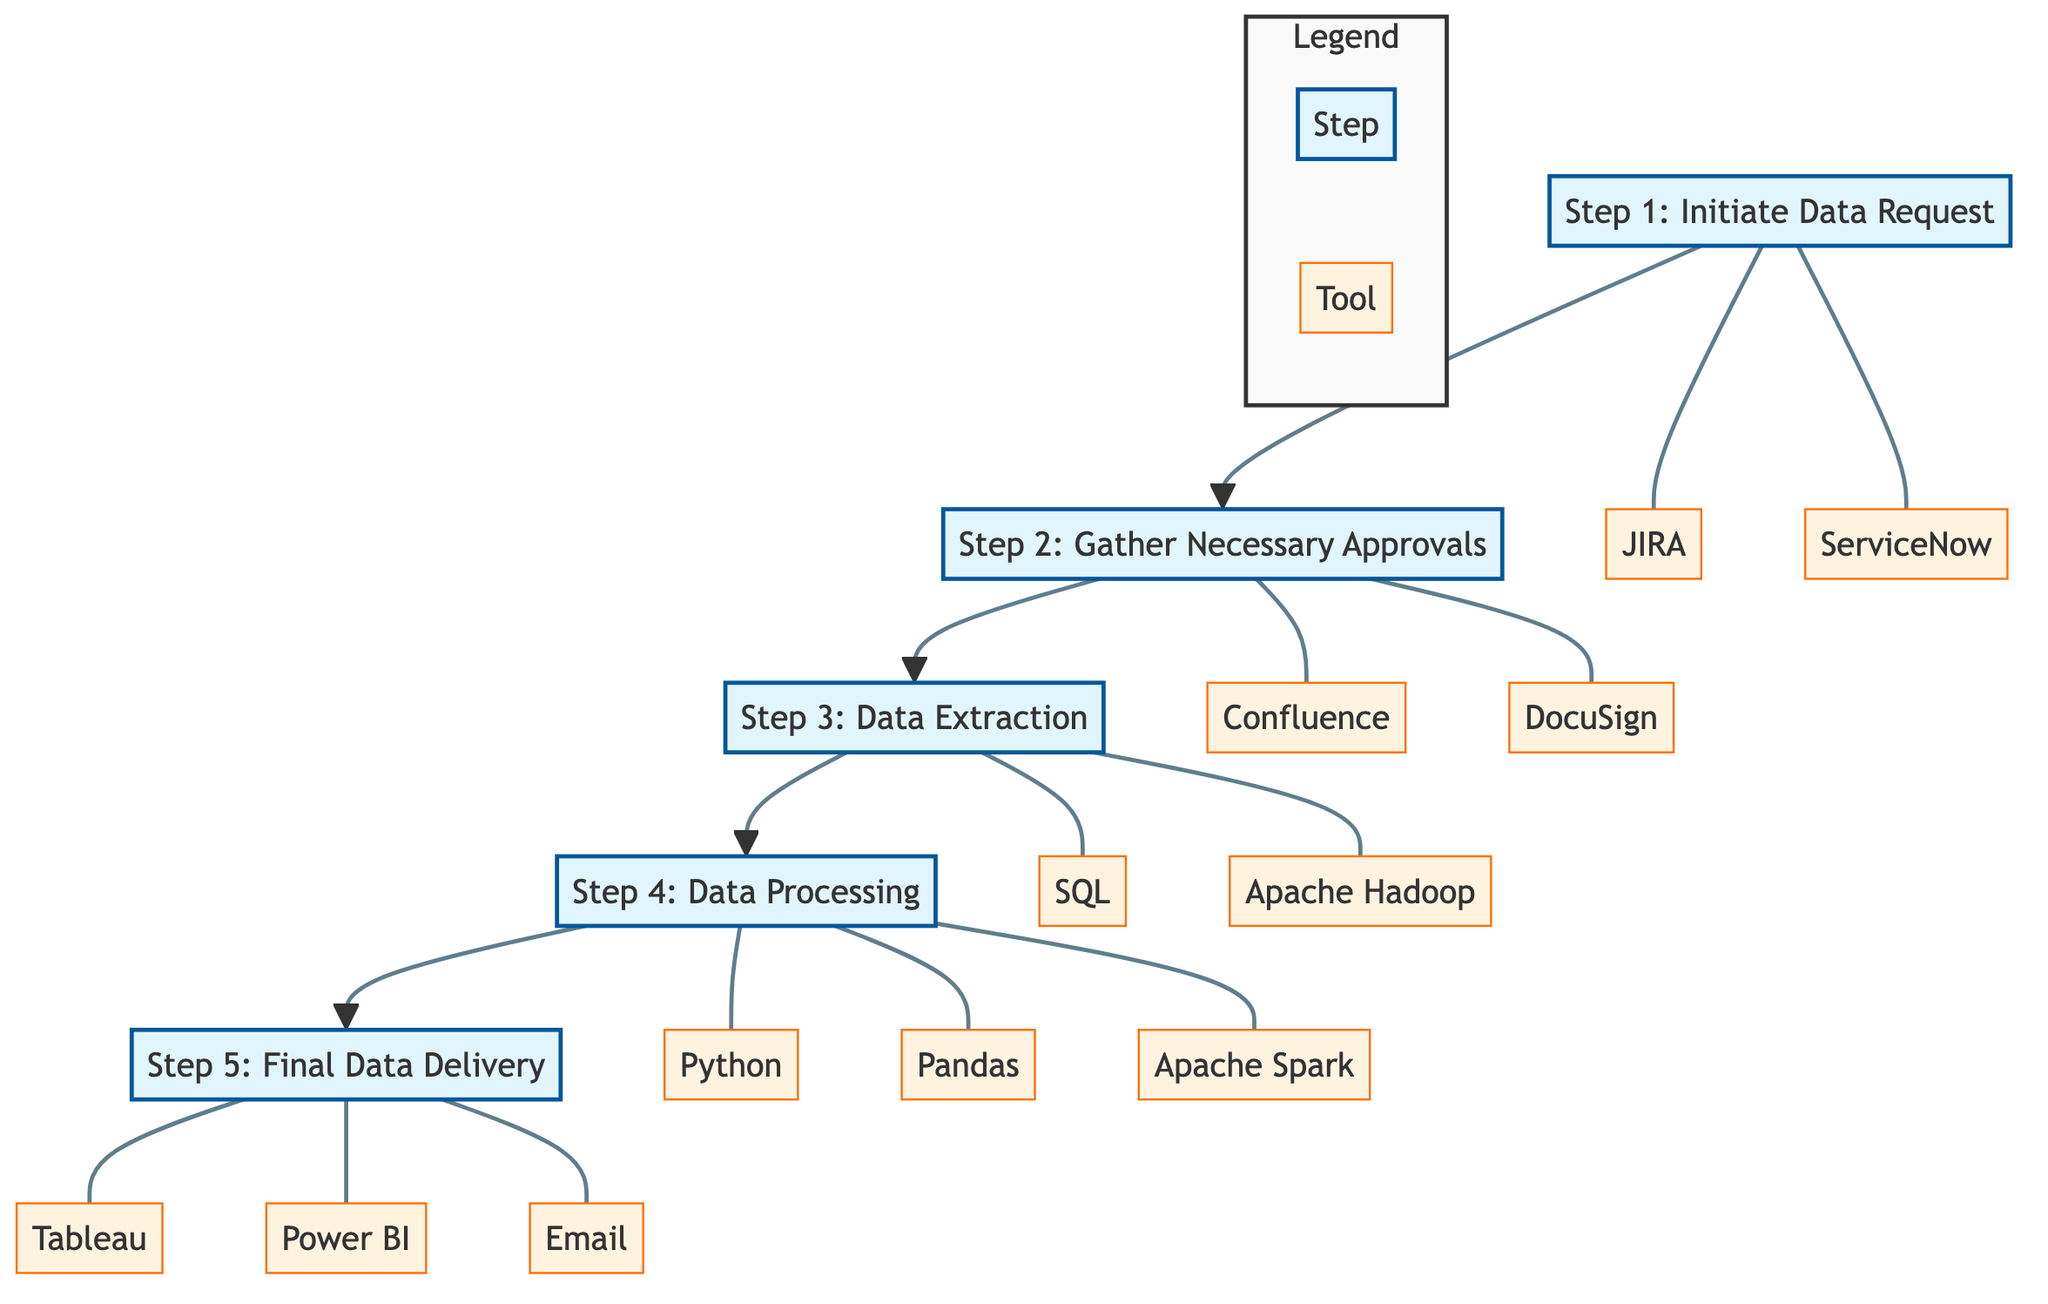What is the first step in the data request journey? The first step listed in the diagram is "Step 1: Initiate Data Request." This step indicates that a team member submits a formal request detailing the dataset and its purpose.
Answer: Step 1: Initiate Data Request Which party is responsible for gathering necessary approvals? The diagram specifies that the "Data Governance Team" is responsible for gathering necessary approvals before moving forward with the data request.
Answer: Data Governance Team How many tools are associated with Step 4: Data Processing? In the diagram, Step 4 lists three tools: Python, Pandas, and Apache Spark. Therefore, there are a total of three tools associated with this step.
Answer: 3 What is the relationship between Step 2 and Step 3? The diagram shows a direct flow from Step 2 ("Gather Necessary Approvals") to Step 3 ("Data Extraction"). This indicates that after approvals are gathered, the next logical step is to extract data.
Answer: Direct flow What tools are used in Step 1? The diagram for Step 1 indicates that two tools are used: JIRA and ServiceNow. Thus, the tools utilized in this step are these two applications.
Answer: JIRA, ServiceNow Identify the last step in the data request process. According to the diagram, the last step presented is "Step 5: Final Data Delivery," which signifies the completion of the data request process.
Answer: Step 5: Final Data Delivery Which step requires the use of SQL? The diagram shows that SQL is utilized in "Step 3: Data Extraction." Thus, the step that requires the use of SQL is this extraction phase.
Answer: Step 3: Data Extraction What step follows Step 4? Following "Step 4: Data Processing," the next indicated step in the diagram is "Step 5: Final Data Delivery." This illustrates the sequential nature of the process.
Answer: Step 5: Final Data Delivery What is unique about the flow direction in this diagram? The diagram depicts a Bottom to Top flow which categorizes the data request journey starting from initiation at the bottom and culminating in delivery at the top. This characteristic is specific to flow charts designed in a bottom-to-top manner.
Answer: Bottom to Top flow 